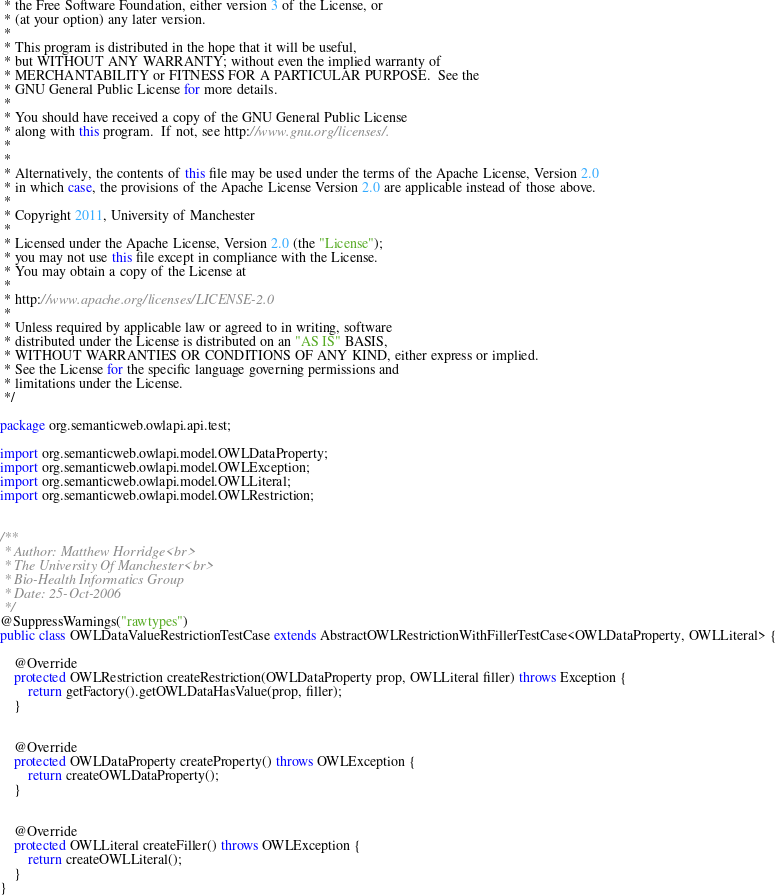<code> <loc_0><loc_0><loc_500><loc_500><_Java_> * the Free Software Foundation, either version 3 of the License, or
 * (at your option) any later version.
 *
 * This program is distributed in the hope that it will be useful,
 * but WITHOUT ANY WARRANTY; without even the implied warranty of
 * MERCHANTABILITY or FITNESS FOR A PARTICULAR PURPOSE.  See the
 * GNU General Public License for more details.
 *
 * You should have received a copy of the GNU General Public License
 * along with this program.  If not, see http://www.gnu.org/licenses/.
 *
 *
 * Alternatively, the contents of this file may be used under the terms of the Apache License, Version 2.0
 * in which case, the provisions of the Apache License Version 2.0 are applicable instead of those above.
 *
 * Copyright 2011, University of Manchester
 *
 * Licensed under the Apache License, Version 2.0 (the "License");
 * you may not use this file except in compliance with the License.
 * You may obtain a copy of the License at
 *
 * http://www.apache.org/licenses/LICENSE-2.0
 *
 * Unless required by applicable law or agreed to in writing, software
 * distributed under the License is distributed on an "AS IS" BASIS,
 * WITHOUT WARRANTIES OR CONDITIONS OF ANY KIND, either express or implied.
 * See the License for the specific language governing permissions and
 * limitations under the License.
 */

package org.semanticweb.owlapi.api.test;

import org.semanticweb.owlapi.model.OWLDataProperty;
import org.semanticweb.owlapi.model.OWLException;
import org.semanticweb.owlapi.model.OWLLiteral;
import org.semanticweb.owlapi.model.OWLRestriction;


/**
 * Author: Matthew Horridge<br>
 * The University Of Manchester<br>
 * Bio-Health Informatics Group
 * Date: 25-Oct-2006
 */
@SuppressWarnings("rawtypes")
public class OWLDataValueRestrictionTestCase extends AbstractOWLRestrictionWithFillerTestCase<OWLDataProperty, OWLLiteral> {

    @Override
	protected OWLRestriction createRestriction(OWLDataProperty prop, OWLLiteral filler) throws Exception {
        return getFactory().getOWLDataHasValue(prop, filler);
    }


    @Override
	protected OWLDataProperty createProperty() throws OWLException {
        return createOWLDataProperty();
    }


    @Override
	protected OWLLiteral createFiller() throws OWLException {
        return createOWLLiteral();
    }
}
</code> 